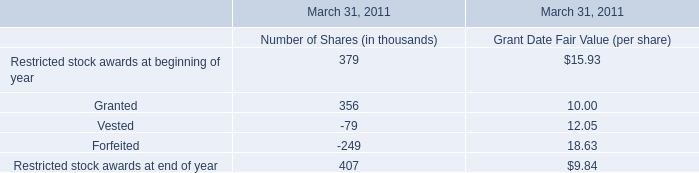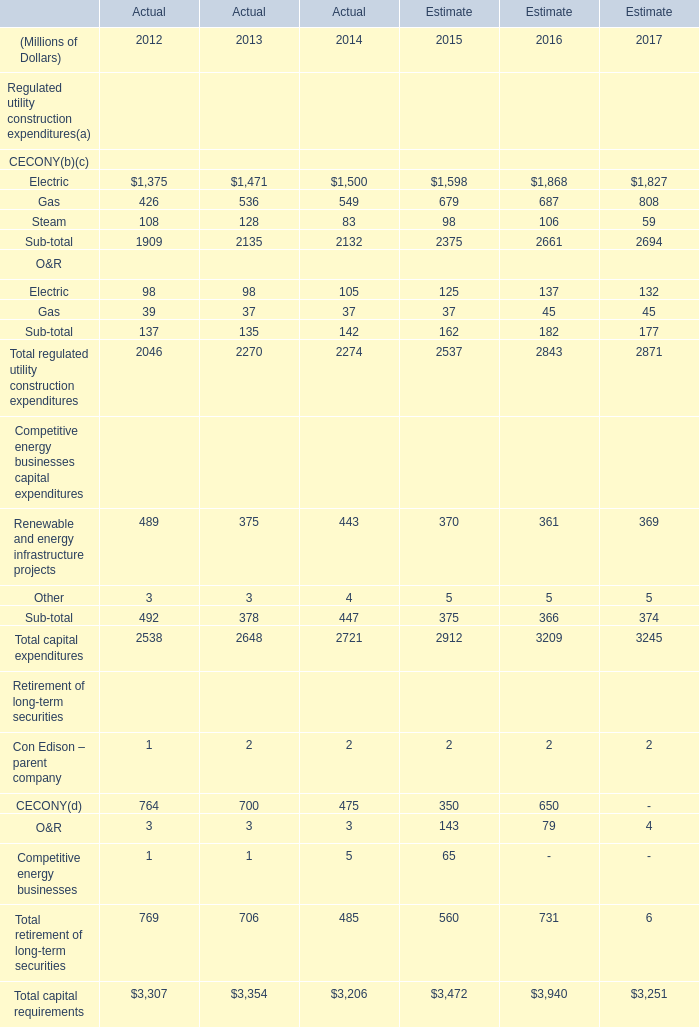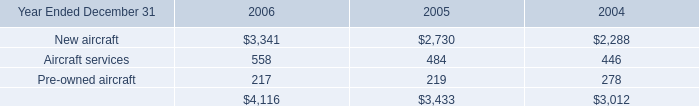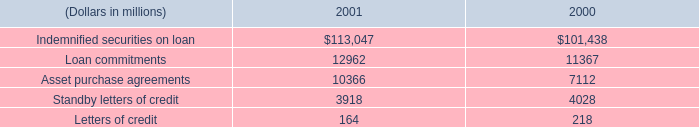What is the average amount of New aircraft of 2004, and Standby letters of credit of 2000 ? 
Computations: ((2288.0 + 4028.0) / 2)
Answer: 3158.0. 